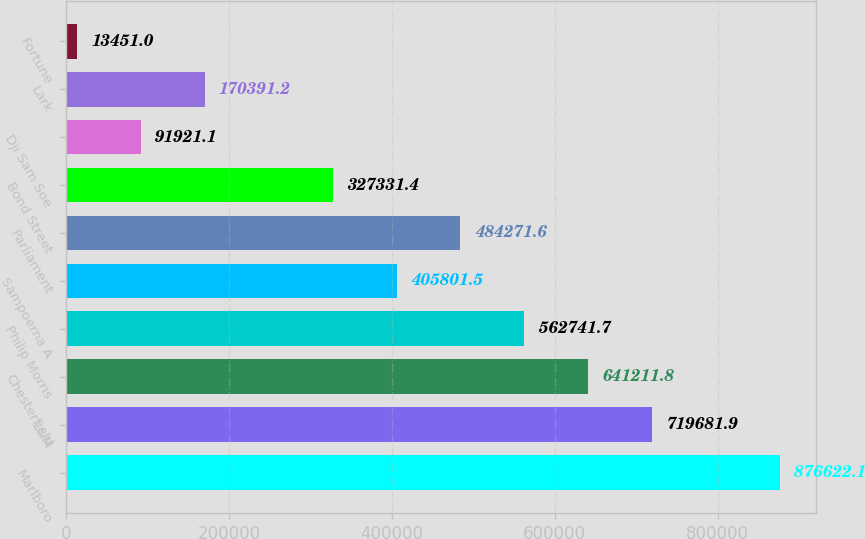Convert chart to OTSL. <chart><loc_0><loc_0><loc_500><loc_500><bar_chart><fcel>Marlboro<fcel>L&M<fcel>Chesterfield<fcel>Philip Morris<fcel>Sampoerna A<fcel>Parliament<fcel>Bond Street<fcel>Dji Sam Soe<fcel>Lark<fcel>Fortune<nl><fcel>876622<fcel>719682<fcel>641212<fcel>562742<fcel>405802<fcel>484272<fcel>327331<fcel>91921.1<fcel>170391<fcel>13451<nl></chart> 